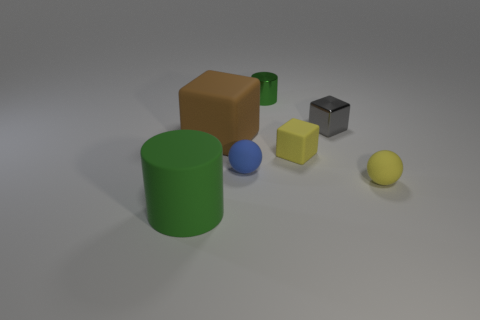What shape is the rubber object that is the same color as the metallic cylinder?
Give a very brief answer. Cylinder. Is there another cylinder that has the same color as the matte cylinder?
Give a very brief answer. Yes. There is a thing that is the same color as the shiny cylinder; what size is it?
Your answer should be very brief. Large. There is a rubber thing that is in front of the blue ball and right of the large green cylinder; what shape is it?
Make the answer very short. Sphere. How many other objects are the same shape as the gray metallic thing?
Ensure brevity in your answer.  2. How big is the green matte object?
Your response must be concise. Large. How many objects are either red rubber cylinders or blue things?
Offer a terse response. 1. There is a green cylinder that is behind the yellow ball; what size is it?
Keep it short and to the point. Small. There is a block that is right of the big matte block and in front of the gray cube; what color is it?
Provide a succinct answer. Yellow. Is the material of the green cylinder that is behind the big matte block the same as the yellow block?
Ensure brevity in your answer.  No. 